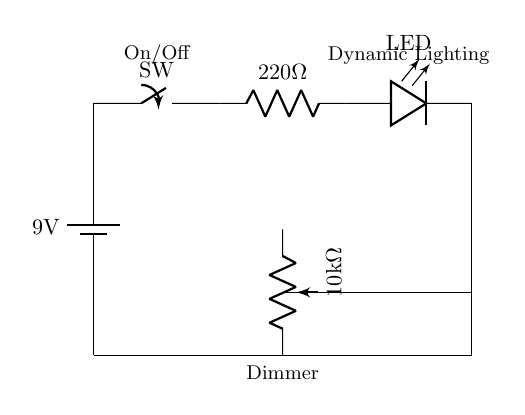What is the voltage of the battery in this circuit? The voltage of the battery is labeled as 9 volts, which indicates the potential difference provided by the source.
Answer: 9 volts What is the resistance value of the resistor in this circuit? The resistor is labeled with a value of 220 ohms, which represents its resistance to current flow.
Answer: 220 ohms What component is used to dim the LED light? A potentiometer, noted as a 10 kilohm variable resistor, is used to adjust the brightness of the LED.
Answer: Potentiometer Which component controls the on and off state of this lighting circuit? The switch, labeled as SW, is responsible for toggling the circuit on and off.
Answer: Switch How many components are connected in series in this circuit? The components in series include the battery, switch, resistor, and LED, totaling four essential components.
Answer: Four What effect does adjusting the dimmer have on the circuit? Adjusting the dimmer (potentiometer) changes the resistance, which alters the current flowing through the LED, allowing for variable brightness.
Answer: Variable brightness What is the purpose of the LED in this circuit? The LED acts as an indicator and provides illumination, enhancing dynamic lighting effects in an animation studio setting.
Answer: Illumination 